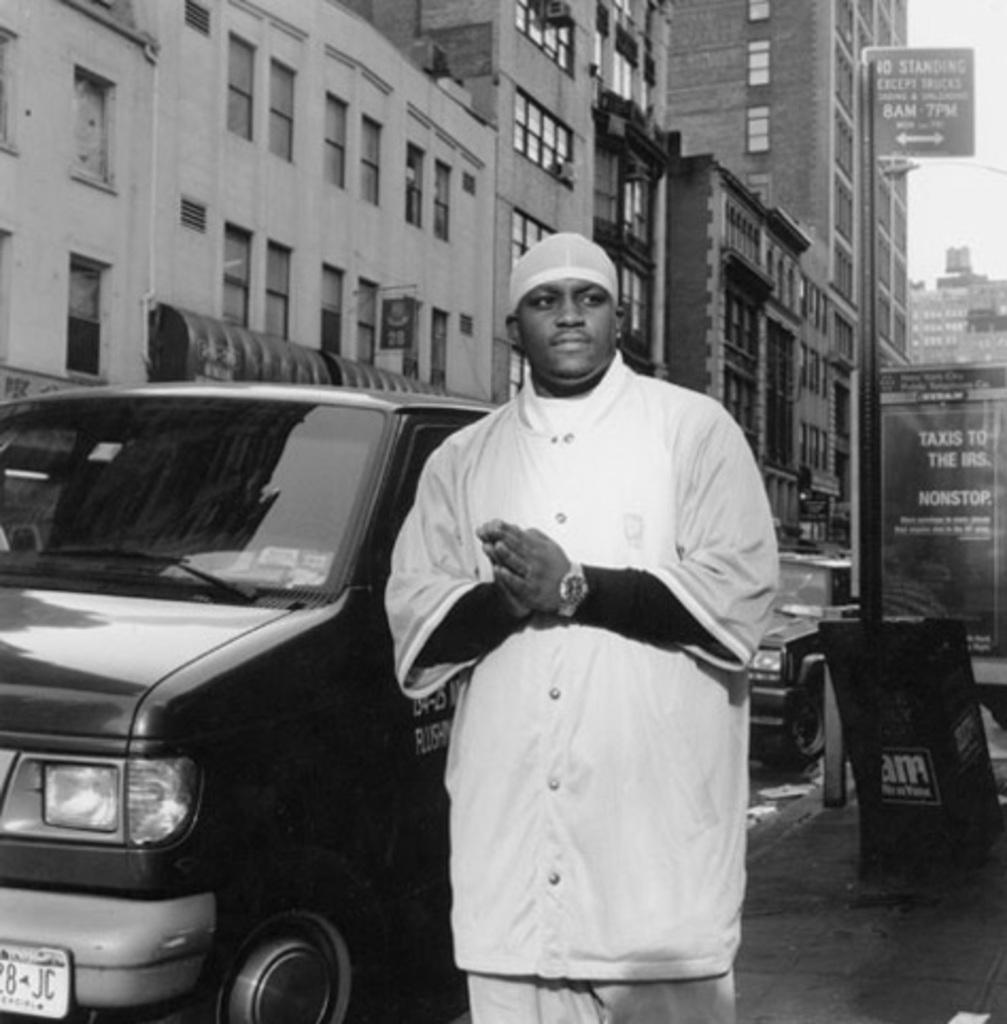<image>
Provide a brief description of the given image. An ad behind a man reads, "Taxis to the IRS." 